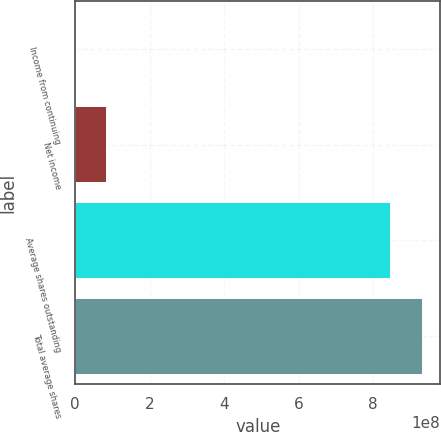Convert chart. <chart><loc_0><loc_0><loc_500><loc_500><bar_chart><fcel>Income from continuing<fcel>Net income<fcel>Average shares outstanding<fcel>Total average shares<nl><fcel>1581<fcel>8.52349e+07<fcel>8.4874e+08<fcel>9.33974e+08<nl></chart> 